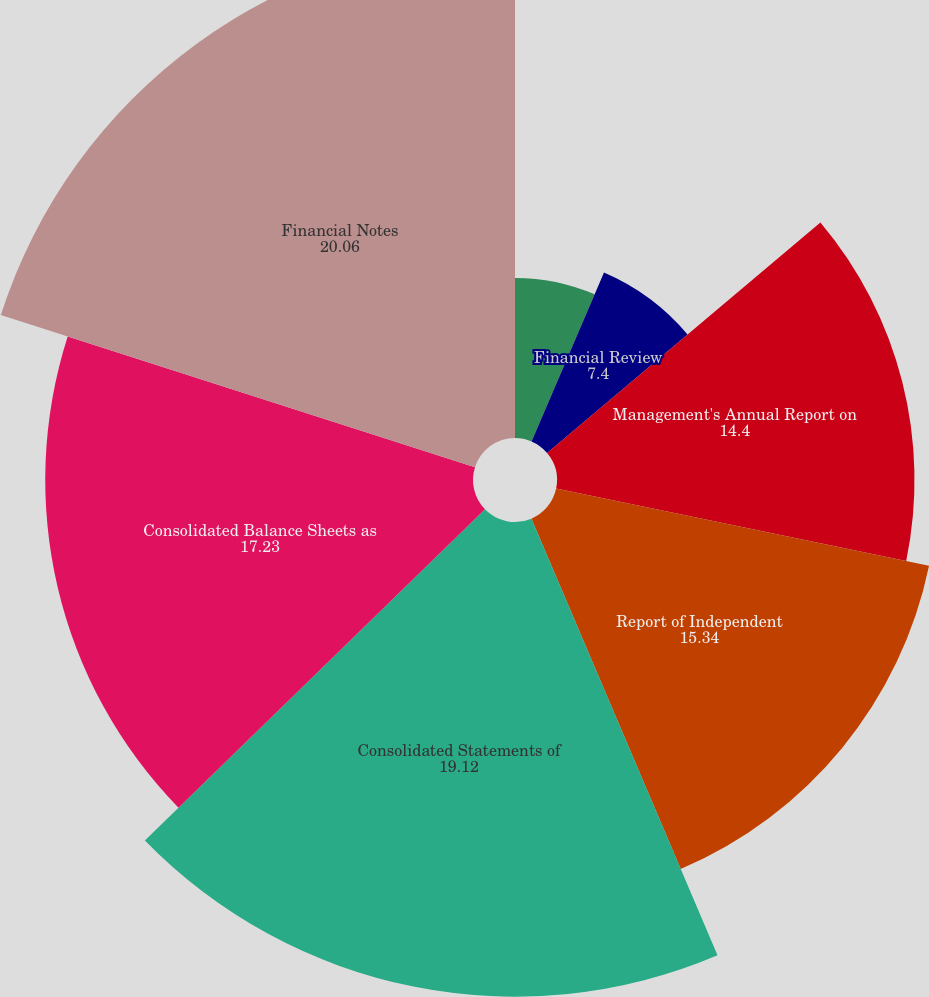<chart> <loc_0><loc_0><loc_500><loc_500><pie_chart><fcel>Five-Year Highlights<fcel>Financial Review<fcel>Management's Annual Report on<fcel>Report of Independent<fcel>Consolidated Statements of<fcel>Consolidated Balance Sheets as<fcel>Financial Notes<nl><fcel>6.45%<fcel>7.4%<fcel>14.4%<fcel>15.34%<fcel>19.12%<fcel>17.23%<fcel>20.06%<nl></chart> 